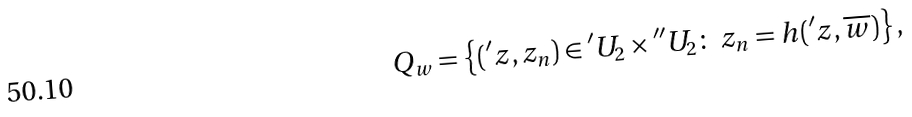<formula> <loc_0><loc_0><loc_500><loc_500>Q _ { w } = \left \{ ( { ^ { \prime } z } , z _ { n } ) \in { ^ { \prime } U _ { 2 } } \times { ^ { \prime \prime } U _ { 2 } } \colon \ z _ { n } = h ( { ^ { \prime } z } , \overline { w } ) \right \} ,</formula> 